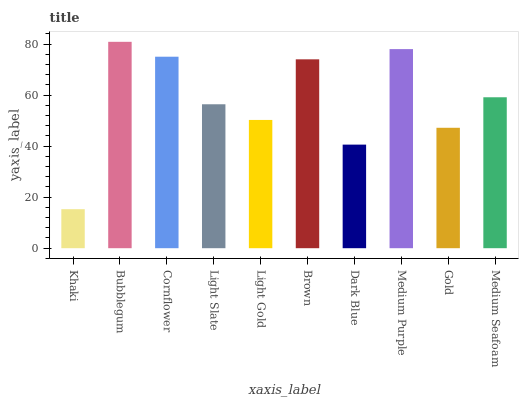Is Cornflower the minimum?
Answer yes or no. No. Is Cornflower the maximum?
Answer yes or no. No. Is Bubblegum greater than Cornflower?
Answer yes or no. Yes. Is Cornflower less than Bubblegum?
Answer yes or no. Yes. Is Cornflower greater than Bubblegum?
Answer yes or no. No. Is Bubblegum less than Cornflower?
Answer yes or no. No. Is Medium Seafoam the high median?
Answer yes or no. Yes. Is Light Slate the low median?
Answer yes or no. Yes. Is Khaki the high median?
Answer yes or no. No. Is Brown the low median?
Answer yes or no. No. 